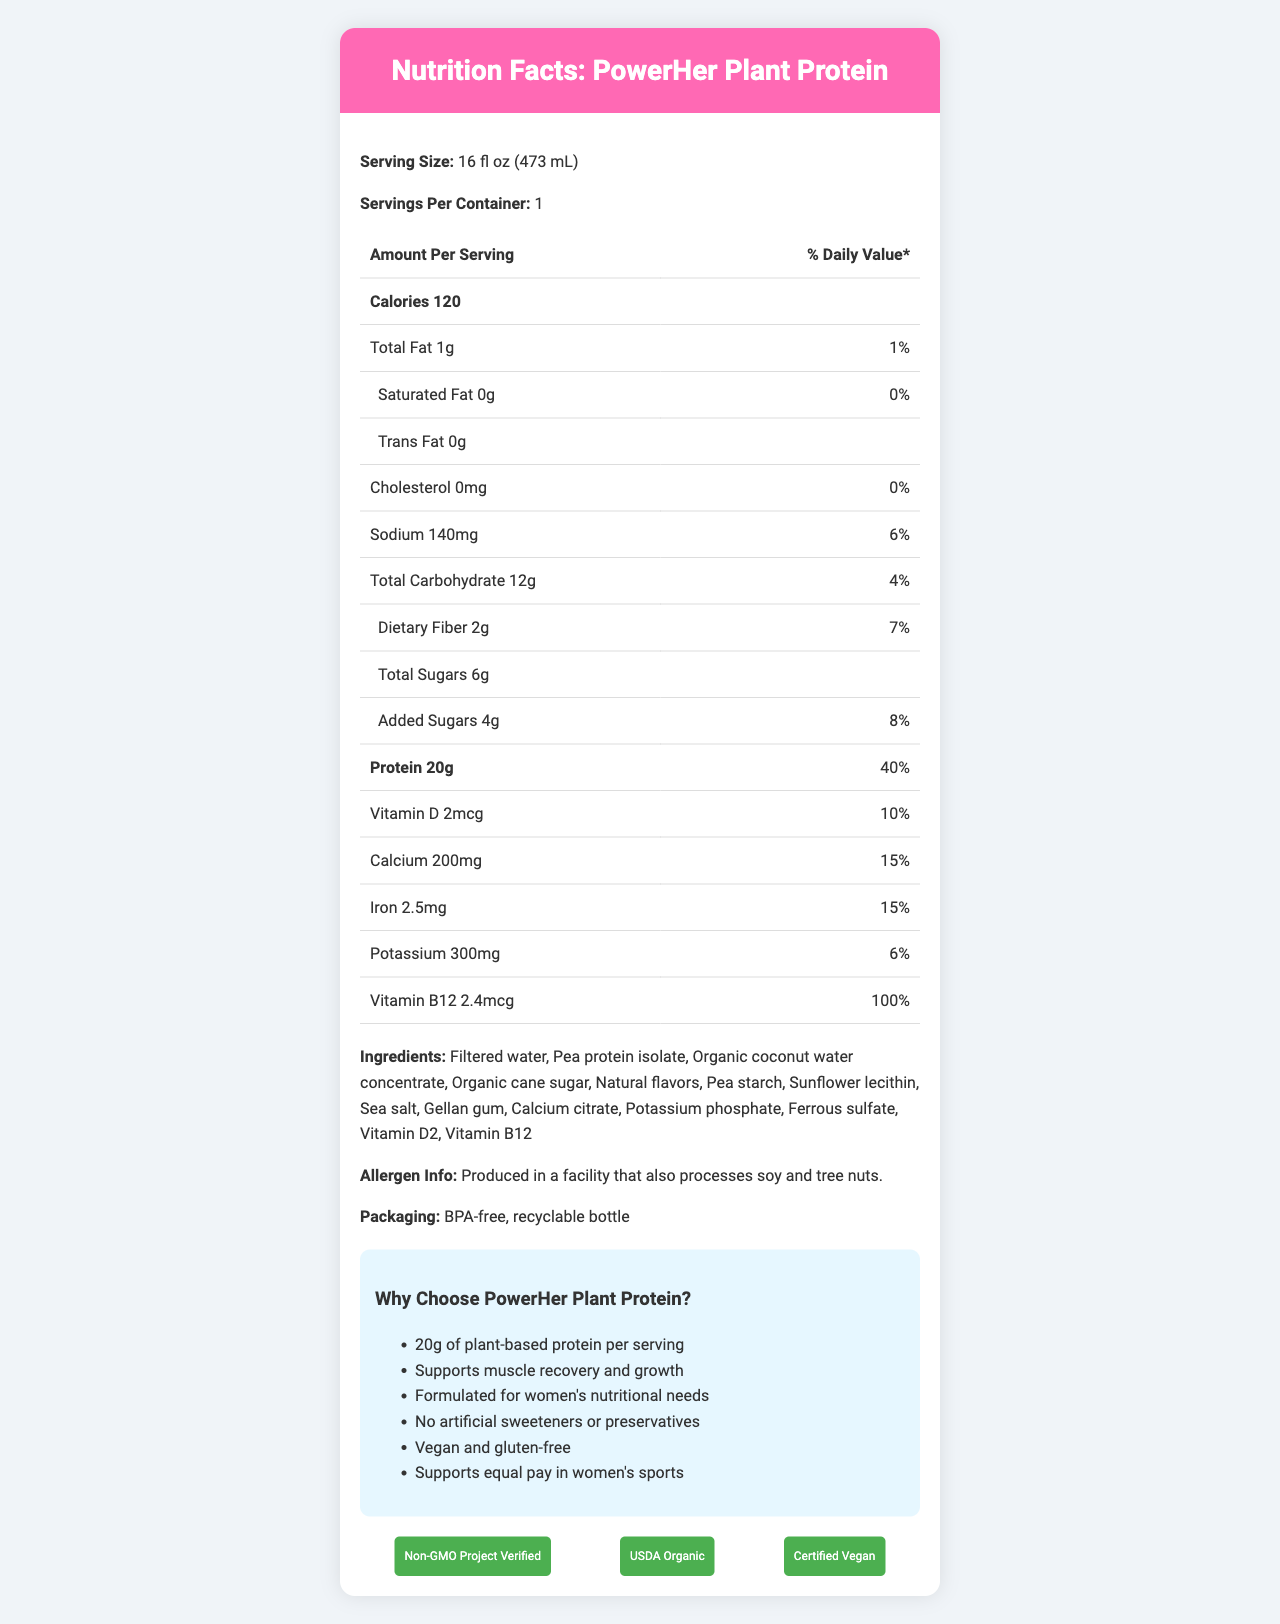What is the serving size of PowerHer Plant Protein? The serving size is specified at the top of the document under "Serving Size".
Answer: 16 fl oz (473 mL) How many calories are there per serving? The document states that there are 120 calories per serving under the "Amount Per Serving" section.
Answer: 120 What is the protein content in one serving of PowerHer Plant Protein? The protein content is listed under the "Protein" section in the nutrition facts table.
Answer: 20g How much sodium does one serving contain, and what percent daily value does this represent? The sodium content is listed in the nutrition facts table, which states 140mg and 6% daily value.
Answer: 140mg, 6% Is PowerHer Plant Protein vegan? The document mentions that the product is "Certified Vegan" in the certifications section and the marketing claims section states "Vegan and gluten-free."
Answer: Yes Which of the following certifications does PowerHer Plant Protein have? A. Non-GMO Project Verified B. Fair Trade Certified C. USDA Organic D. Certified Vegan The certifications listed in the document are "Non-GMO Project Verified," "USDA Organic," and "Certified Vegan."
Answer: A, C, D What percent daily value of Vitamin B12 is provided per serving? A. 10% B. 50% C. 100% D. 25% The nutrition facts table states that one serving of the product provides 100% daily value of Vitamin B12.
Answer: C. 100% Does PowerHer Plant Protein contain any trans fat? The document states "Trans Fat 0g" which means it does not contain any trans fat.
Answer: No Is the product manufactured in a facility that processes soy and tree nuts? The allergen info section specifies that it is produced in a facility that also processes soy and tree nuts.
Answer: Yes Summarize the main idea of the document. The document is a comprehensive nutrition label and marketing sheet for PowerHer Plant Protein, focusing on its nutritional benefits, suitability for female athletes, ingredient transparency, allergen information, and certifications.
Answer: The document provides detailed nutrition facts for PowerHer Plant Protein, a plant-based sports drink designed for female athletes. It highlights its high protein content, key vitamins and minerals, natural ingredients, and certifications like USDA Organic, Non-GMO Project Verified, and Certified Vegan. It also includes marketing claims emphasizing its support for women's sports and its allergen information. What is the total carbohydrate content per serving, and how much of it comes from dietary fiber and added sugars? The nutrition facts table indicates the product contains 12g of total carbohydrates, which includes 2g of dietary fiber and 4g of added sugars.
Answer: 12g total, 2g dietary fiber, 4g added sugars How does PowerHer Plant Protein support women's nutritional needs? The document states that the product is "Formulated for women's nutritional needs" and highlights its high protein content and key nutrients like Calcium, Iron, and Vitamin B12.
Answer: It contains 20g of protein, important vitamins and minerals, and is formulated specifically for female athletes. Does the packaging of PowerHer Plant Protein contain BPA? The document mentions that the product uses a "BPA-free, recyclable bottle."
Answer: No What kind of sugar is used in the ingredients? The ingredients list specifies "Organic cane sugar" as one of the components.
Answer: Organic cane sugar How much Vitamin D does one serving of PowerHer Plant Protein provide, and what percent of the daily value does this represent? The nutrition facts table indicates that one serving provides 2mcg of Vitamin D, representing 10% of the daily value.
Answer: 2mcg, 10% Does the drink contain any artificial sweeteners or preservatives? The marketing claims emphasize that the product is made without artificial sweeteners or preservatives.
Answer: No How much calcium is provided per serving of PowerHer Plant Protein? The nutrition facts table states that each serving contains 200mg of calcium.
Answer: 200mg Where is the sports drink marketed towards? The document and marketing claims stress that the product is specifically formulated for women's nutritional needs and supports equal pay in women's sports.
Answer: Female athletes What specific initiatives does PowerHer Plant Protein support as part of its marketing claims? The marketing claims section includes "Supports equal pay in women's sports" as one of its initiatives.
Answer: Supports equal pay in women's sports How much potassium does the drink contain per serving? The nutrition facts table lists that the drink contains 300mg of potassium per serving.
Answer: 300mg What is the main protein source in PowerHer Plant Protein? The ingredients list specifies "Pea protein isolate" as the primary protein source.
Answer: Pea protein isolate Does the product contain soy? The allergen info states that it is produced in a facility that processes soy, but it does not confirm whether the product itself contains soy.
Answer: Cannot be determined 